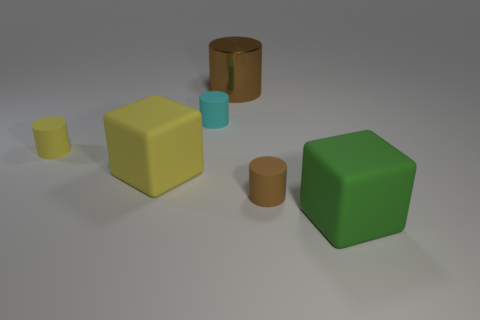How could light and shadow give us clues about the placement of objects in this space? The light source appears to be coming from the top-left, casting shadows towards the bottom-right. The length and direction of the shadows can indicate the relative positions and heights of the objects, as the shadows of the taller objects extend further into the scene. 